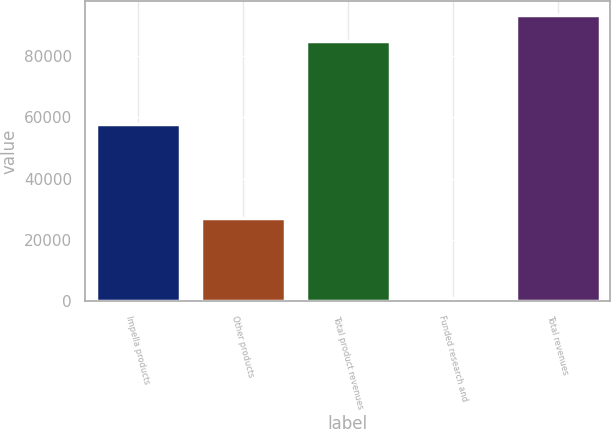Convert chart to OTSL. <chart><loc_0><loc_0><loc_500><loc_500><bar_chart><fcel>Impella products<fcel>Other products<fcel>Total product revenues<fcel>Funded research and<fcel>Total revenues<nl><fcel>57799<fcel>26966<fcel>84765<fcel>948<fcel>93241.5<nl></chart> 